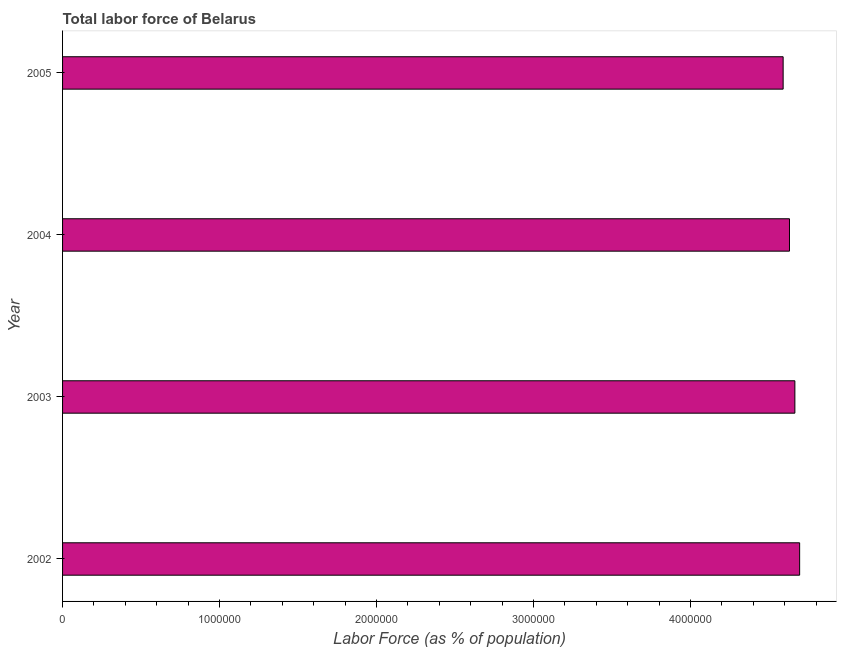Does the graph contain any zero values?
Keep it short and to the point. No. Does the graph contain grids?
Ensure brevity in your answer.  No. What is the title of the graph?
Give a very brief answer. Total labor force of Belarus. What is the label or title of the X-axis?
Provide a short and direct response. Labor Force (as % of population). What is the total labor force in 2005?
Provide a short and direct response. 4.59e+06. Across all years, what is the maximum total labor force?
Keep it short and to the point. 4.70e+06. Across all years, what is the minimum total labor force?
Provide a short and direct response. 4.59e+06. In which year was the total labor force minimum?
Your answer should be compact. 2005. What is the sum of the total labor force?
Your answer should be compact. 1.86e+07. What is the difference between the total labor force in 2002 and 2005?
Give a very brief answer. 1.05e+05. What is the average total labor force per year?
Your response must be concise. 4.65e+06. What is the median total labor force?
Make the answer very short. 4.65e+06. Is the total labor force in 2002 less than that in 2005?
Provide a succinct answer. No. What is the difference between the highest and the second highest total labor force?
Offer a terse response. 3.04e+04. Is the sum of the total labor force in 2004 and 2005 greater than the maximum total labor force across all years?
Give a very brief answer. Yes. What is the difference between the highest and the lowest total labor force?
Your answer should be compact. 1.05e+05. In how many years, is the total labor force greater than the average total labor force taken over all years?
Ensure brevity in your answer.  2. Are all the bars in the graph horizontal?
Your answer should be compact. Yes. What is the difference between two consecutive major ticks on the X-axis?
Make the answer very short. 1.00e+06. What is the Labor Force (as % of population) in 2002?
Your answer should be compact. 4.70e+06. What is the Labor Force (as % of population) in 2003?
Make the answer very short. 4.67e+06. What is the Labor Force (as % of population) in 2004?
Your answer should be very brief. 4.63e+06. What is the Labor Force (as % of population) of 2005?
Your answer should be compact. 4.59e+06. What is the difference between the Labor Force (as % of population) in 2002 and 2003?
Your response must be concise. 3.04e+04. What is the difference between the Labor Force (as % of population) in 2002 and 2004?
Your response must be concise. 6.47e+04. What is the difference between the Labor Force (as % of population) in 2002 and 2005?
Ensure brevity in your answer.  1.05e+05. What is the difference between the Labor Force (as % of population) in 2003 and 2004?
Give a very brief answer. 3.44e+04. What is the difference between the Labor Force (as % of population) in 2003 and 2005?
Keep it short and to the point. 7.48e+04. What is the difference between the Labor Force (as % of population) in 2004 and 2005?
Your response must be concise. 4.04e+04. What is the ratio of the Labor Force (as % of population) in 2002 to that in 2003?
Your response must be concise. 1.01. What is the ratio of the Labor Force (as % of population) in 2002 to that in 2004?
Make the answer very short. 1.01. What is the ratio of the Labor Force (as % of population) in 2003 to that in 2005?
Provide a short and direct response. 1.02. What is the ratio of the Labor Force (as % of population) in 2004 to that in 2005?
Keep it short and to the point. 1.01. 